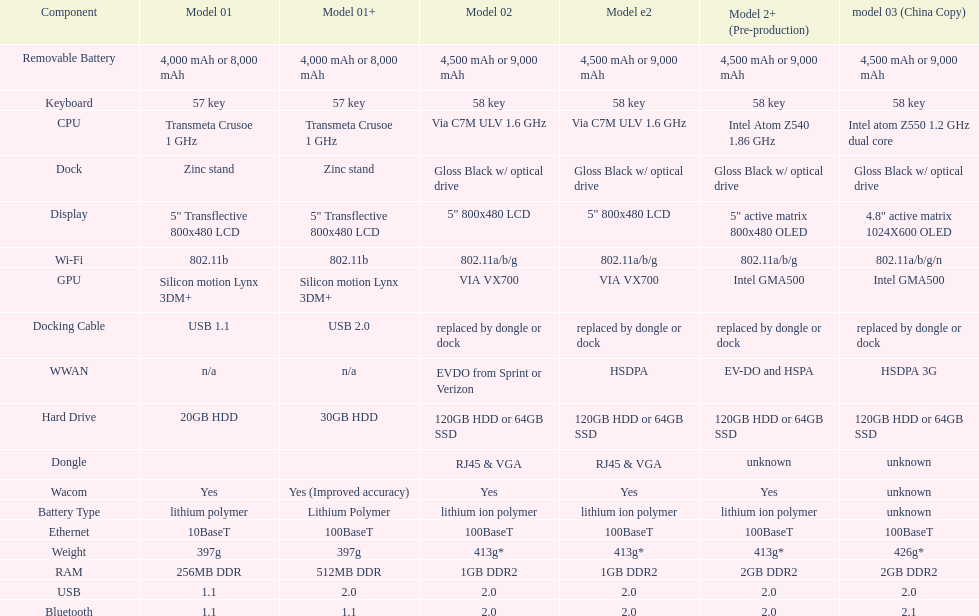How much more weight does the model 3 have over model 1? 29g. 